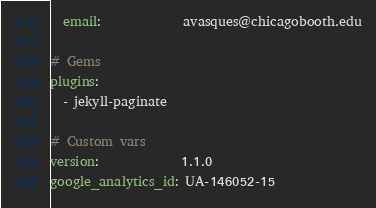Convert code to text. <code><loc_0><loc_0><loc_500><loc_500><_YAML_>  email:             avasques@chicagobooth.edu

# Gems
plugins:
  - jekyll-paginate

# Custom vars
version:             1.1.0
google_analytics_id: UA-146052-15
</code> 